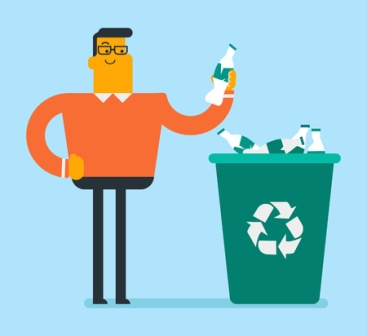What could be a possible backstory for the man in the image? The man in the image might be a dedicated environmentalist who has been passionate about recycling for years. He could work in an office where he advocates for sustainable practices, encouraging his colleagues to recycle and reduce waste. His orange sweater might be part of a company initiative to bring attention to their recycling program, aiming to set a positive example for others. 